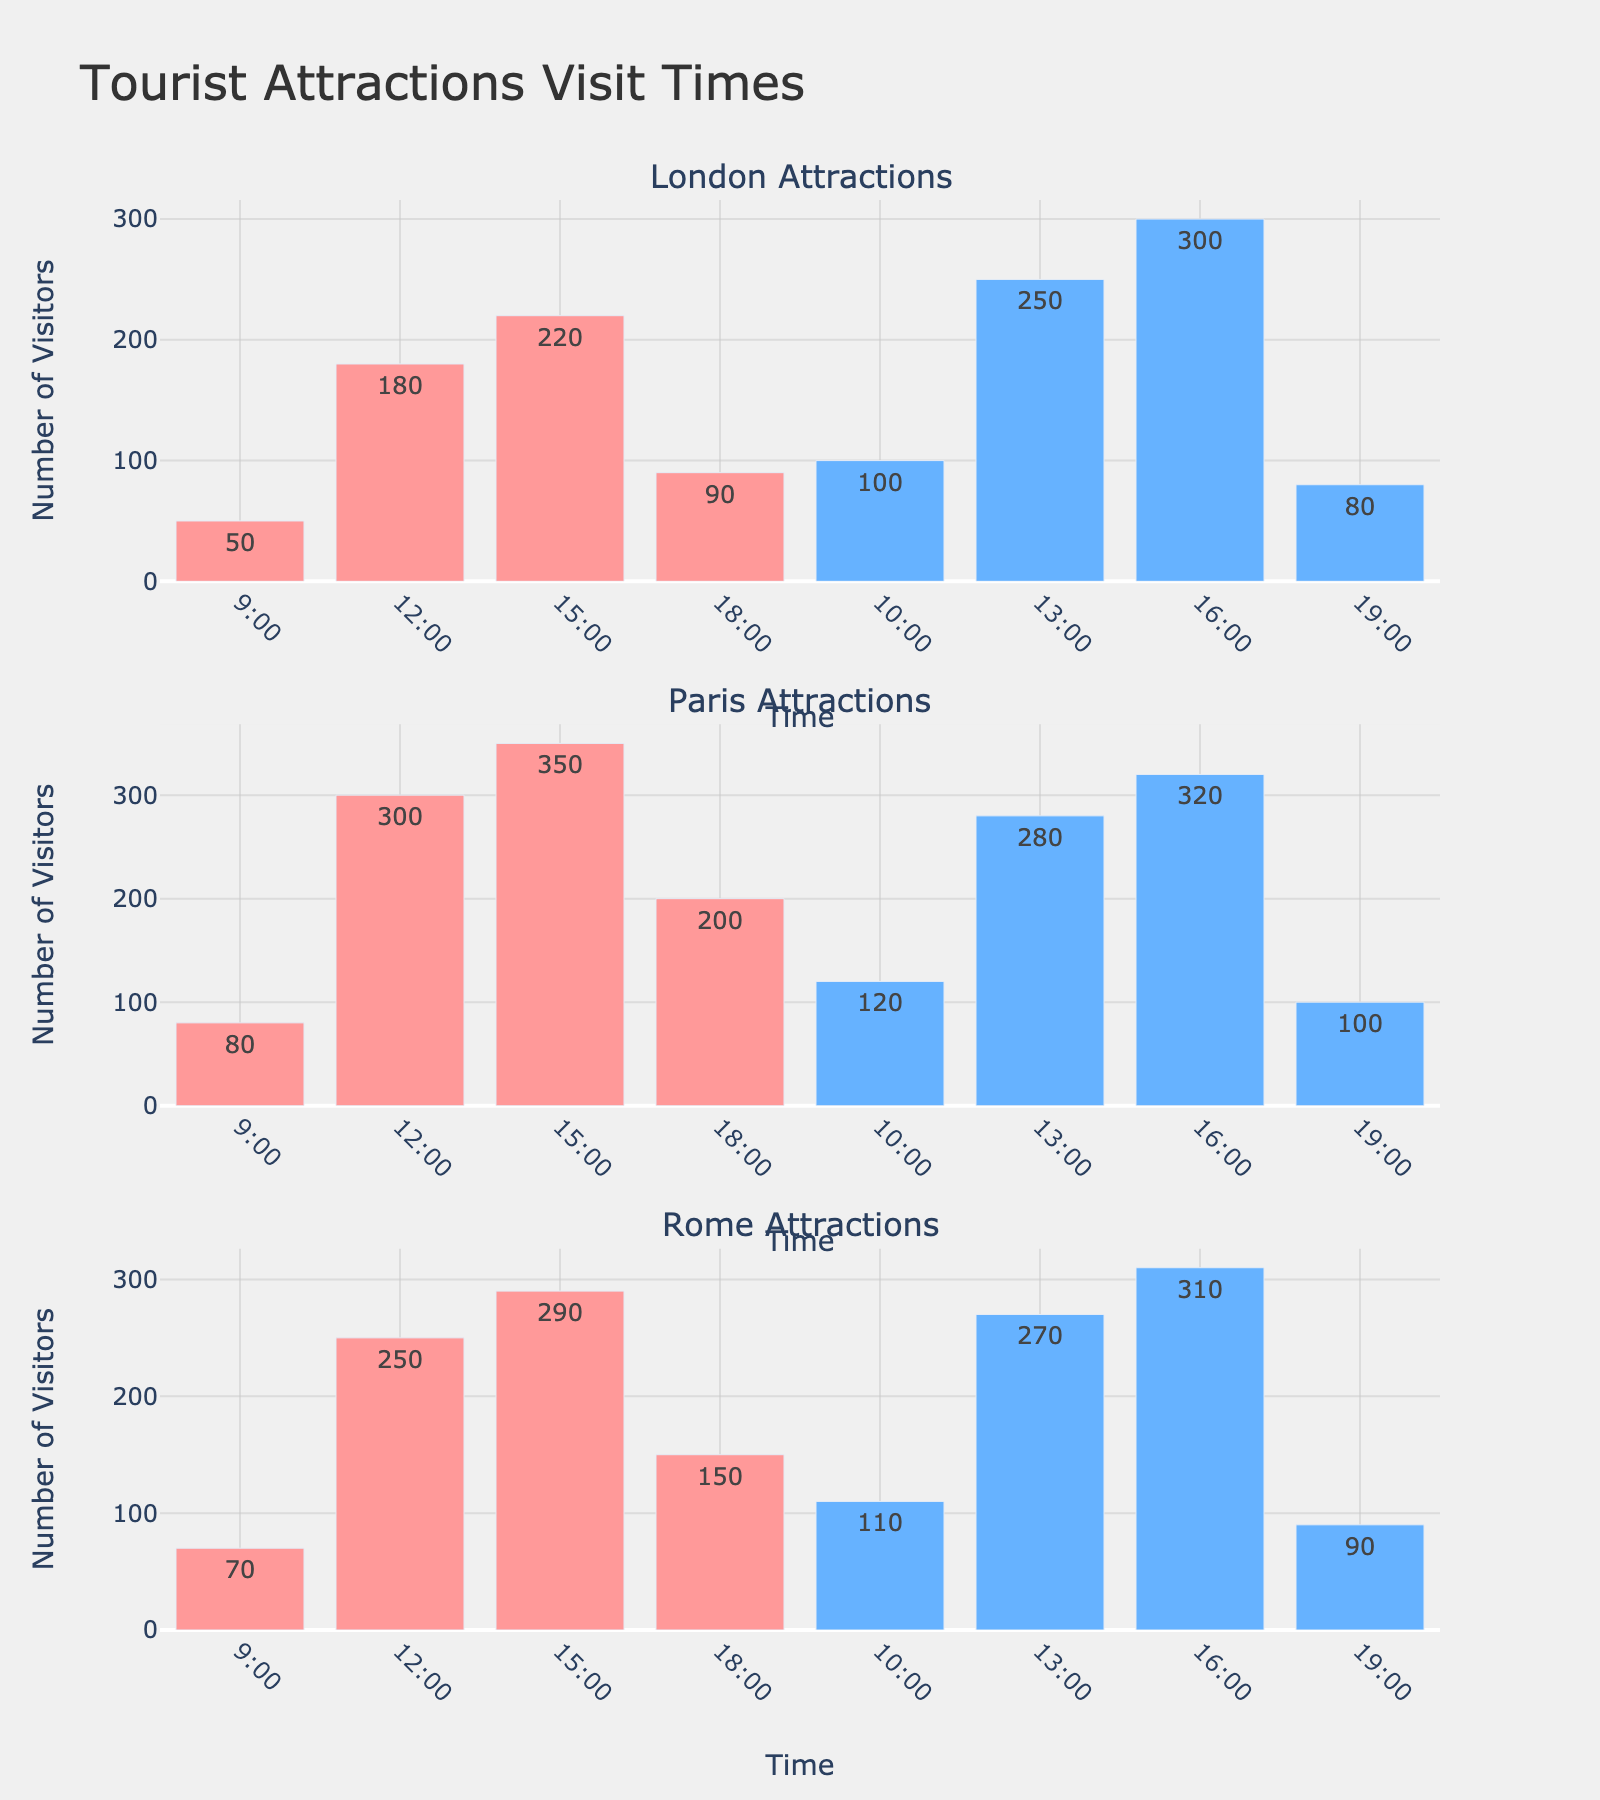What is the title of the figure? The title of the figure is located at the top and reads "Tourist Attractions Visit Times."
Answer: Tourist Attractions Visit Times What time slot had the highest visitor count for the Tower of London in London? By examining the subplot for London, look at the bars corresponding to the Tower of London. The bar for 15:00 has the tallest height, indicating the highest visitor count.
Answer: 15:00 How many visitors visited the British Museum at 13:00 in London? In the London subplot, locate the bar for the British Museum at 13:00. The number labeled on this bar indicates the visitor count.
Answer: 250 Which city among London, Paris, and Rome has the highest visitor count for any single attraction during any time slot? Compare the highest bar in each city's subplot. Paris's Eiffel Tower at 15:00 has the tallest bar with 350 visitors.
Answer: Paris What is the total number of visitors for the Eiffel Tower in Paris throughout the day? Add the visitor counts for the Eiffel Tower across all time slots in the Paris subplot: 80 (9:00) + 300 (12:00) + 350 (15:00) + 200 (18:00) = 930.
Answer: 930 Which attraction in Rome has the highest peak visitor count, and at what time does it occur? In the Rome subplot, compare the peaks of the Colosseum and the Vatican Museums. The tallest peak is for the Vatican Museums at 16:00 with 310 visitors.
Answer: Vatican Museums at 16:00 What is the visitor difference between the Colosseum at 12:00 and 18:00 in Rome? In the Rome subplot, the Colosseum visitor count at 12:00 is 250 and at 18:00 is 150. The difference is 250 - 150 = 100.
Answer: 100 Which time slot experiences the least visitors across all attractions in Paris? Looking at the Paris subplot, find the bar with the smallest height across all attractions and time slots. The 9:00 slot for the Eiffel Tower has the minimum with 80 visitors.
Answer: 9:00 What pattern can be observed in the visitor trends for attractions in London across different time slots? In London's subplot, visitor numbers tend to increase from morning to afternoon and decrease towards the evening for both attractions.
Answer: Increase in the afternoon, decrease in the evening How does the visitor trend for the British Museum in London compare to the Vatican Museums in Rome at 10:00 and 16:00? At 10:00, the British Museum has 100 visitors and the Vatican Museums have 110 visitors. At 16:00, the British Museum has 300 visitors and the Vatican Museums have 310 visitors. Both show a similar increasing trend.
Answer: Similar trends 